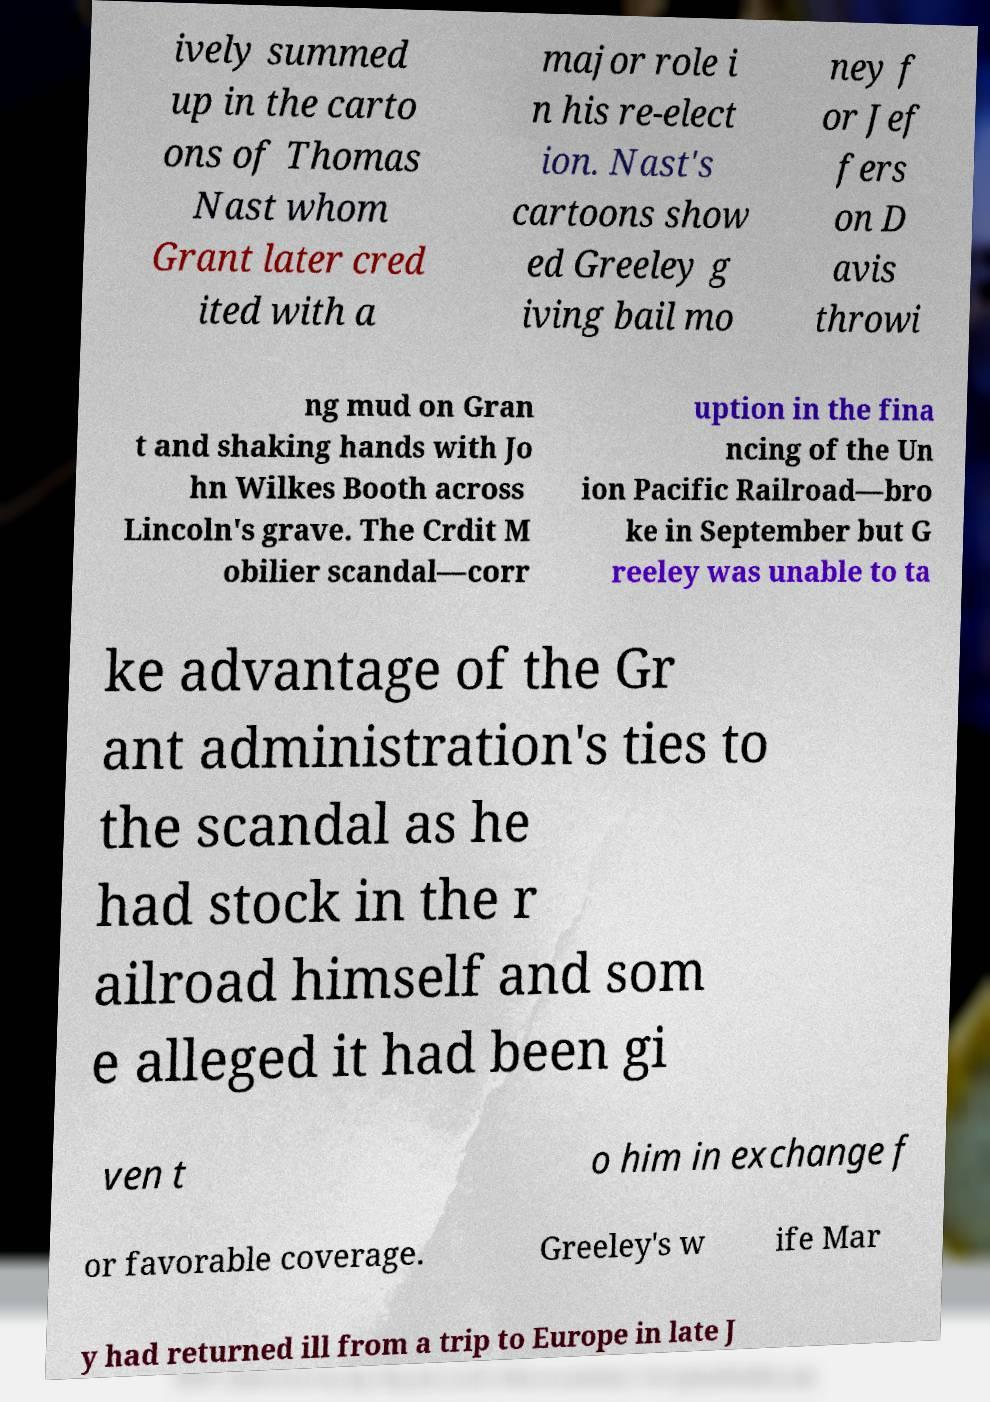Please read and relay the text visible in this image. What does it say? ively summed up in the carto ons of Thomas Nast whom Grant later cred ited with a major role i n his re-elect ion. Nast's cartoons show ed Greeley g iving bail mo ney f or Jef fers on D avis throwi ng mud on Gran t and shaking hands with Jo hn Wilkes Booth across Lincoln's grave. The Crdit M obilier scandal—corr uption in the fina ncing of the Un ion Pacific Railroad—bro ke in September but G reeley was unable to ta ke advantage of the Gr ant administration's ties to the scandal as he had stock in the r ailroad himself and som e alleged it had been gi ven t o him in exchange f or favorable coverage. Greeley's w ife Mar y had returned ill from a trip to Europe in late J 